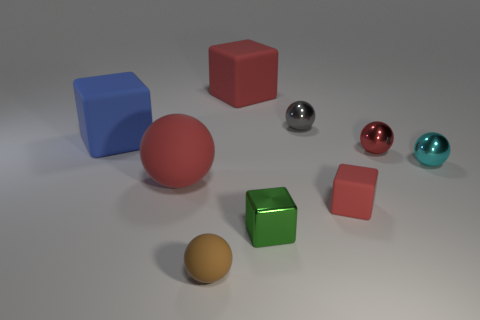Subtract all large red blocks. How many blocks are left? 3 Add 1 small red balls. How many objects exist? 10 Subtract all green cubes. How many cubes are left? 3 Subtract 3 cubes. How many cubes are left? 1 Subtract all spheres. How many objects are left? 4 Subtract all blue cubes. Subtract all yellow spheres. How many cubes are left? 3 Subtract all purple blocks. How many red spheres are left? 2 Subtract all big rubber objects. Subtract all green cubes. How many objects are left? 5 Add 6 gray balls. How many gray balls are left? 7 Add 7 tiny green things. How many tiny green things exist? 8 